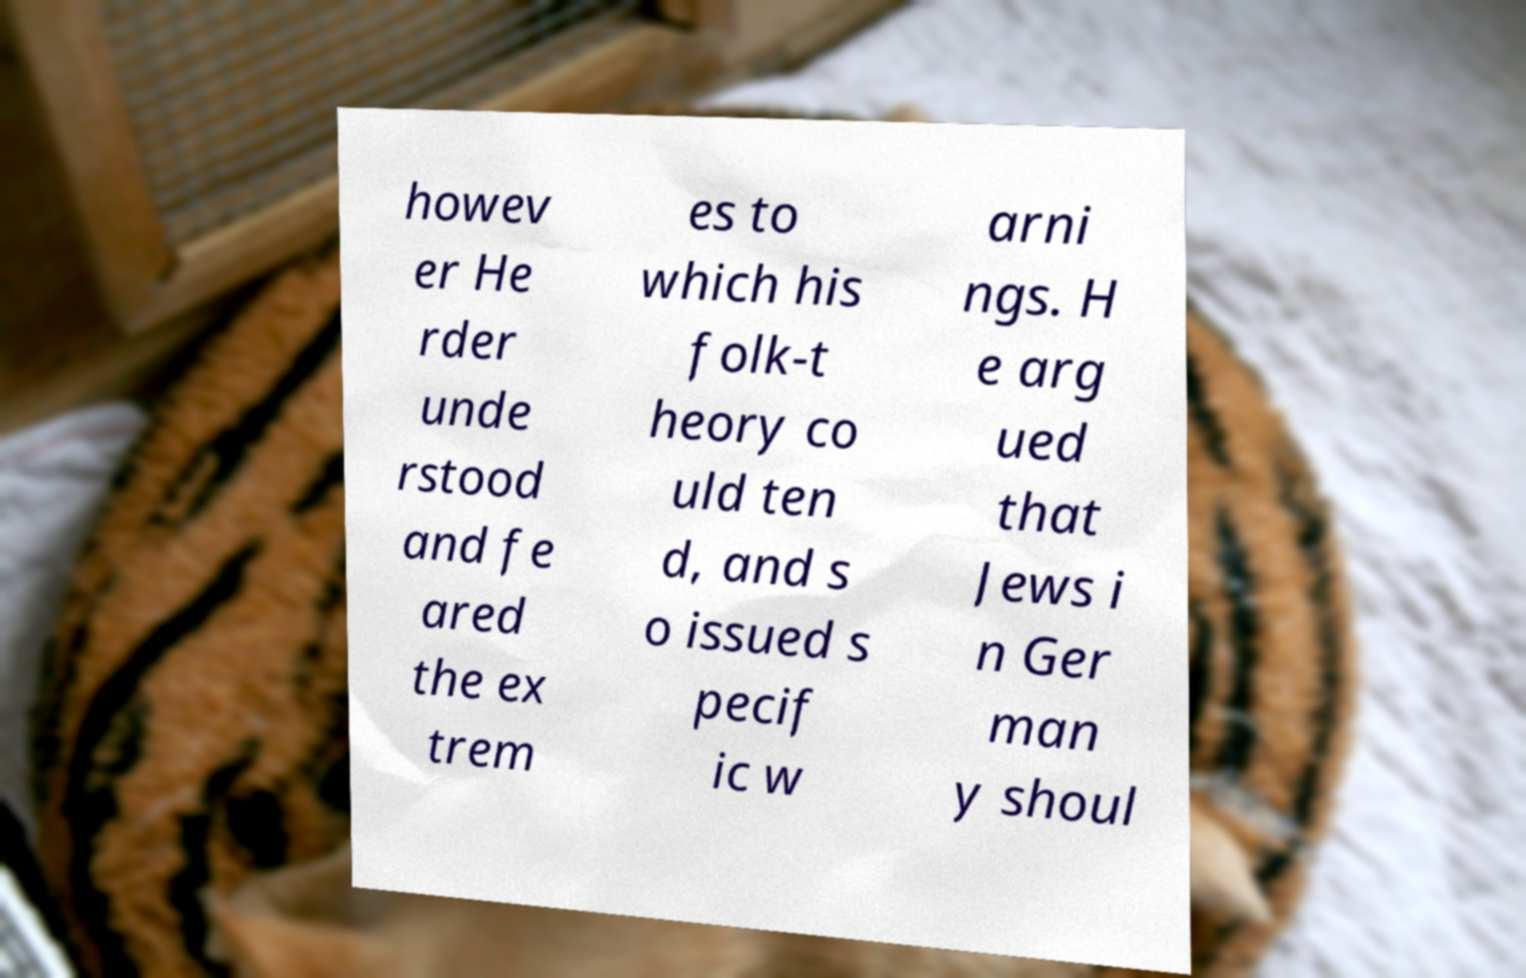Can you read and provide the text displayed in the image?This photo seems to have some interesting text. Can you extract and type it out for me? howev er He rder unde rstood and fe ared the ex trem es to which his folk-t heory co uld ten d, and s o issued s pecif ic w arni ngs. H e arg ued that Jews i n Ger man y shoul 